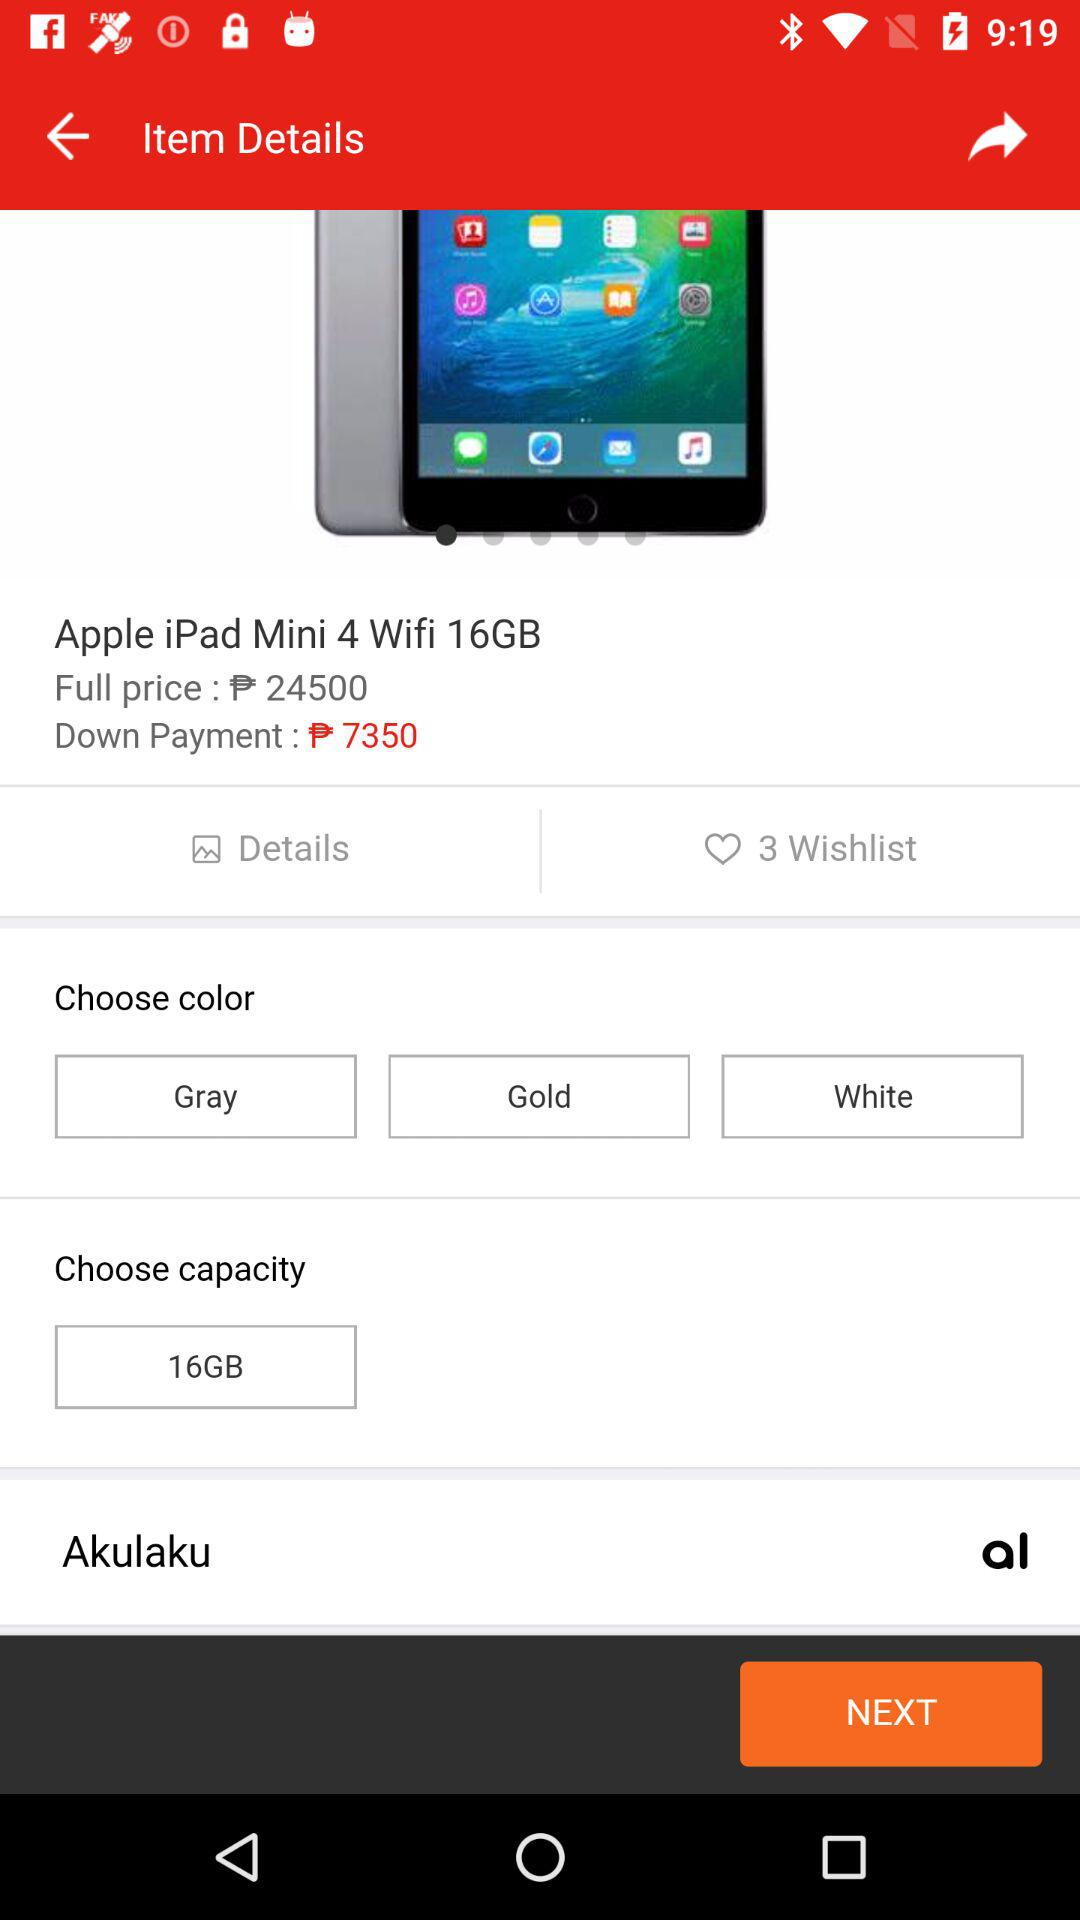What is the capacity? The capacity is 16 GB. 